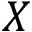Convert formula to latex. <formula><loc_0><loc_0><loc_500><loc_500>X</formula> 